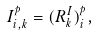Convert formula to latex. <formula><loc_0><loc_0><loc_500><loc_500>I ^ { p } _ { i , k } = ( R ^ { I } _ { k } ) ^ { p } _ { i } ,</formula> 